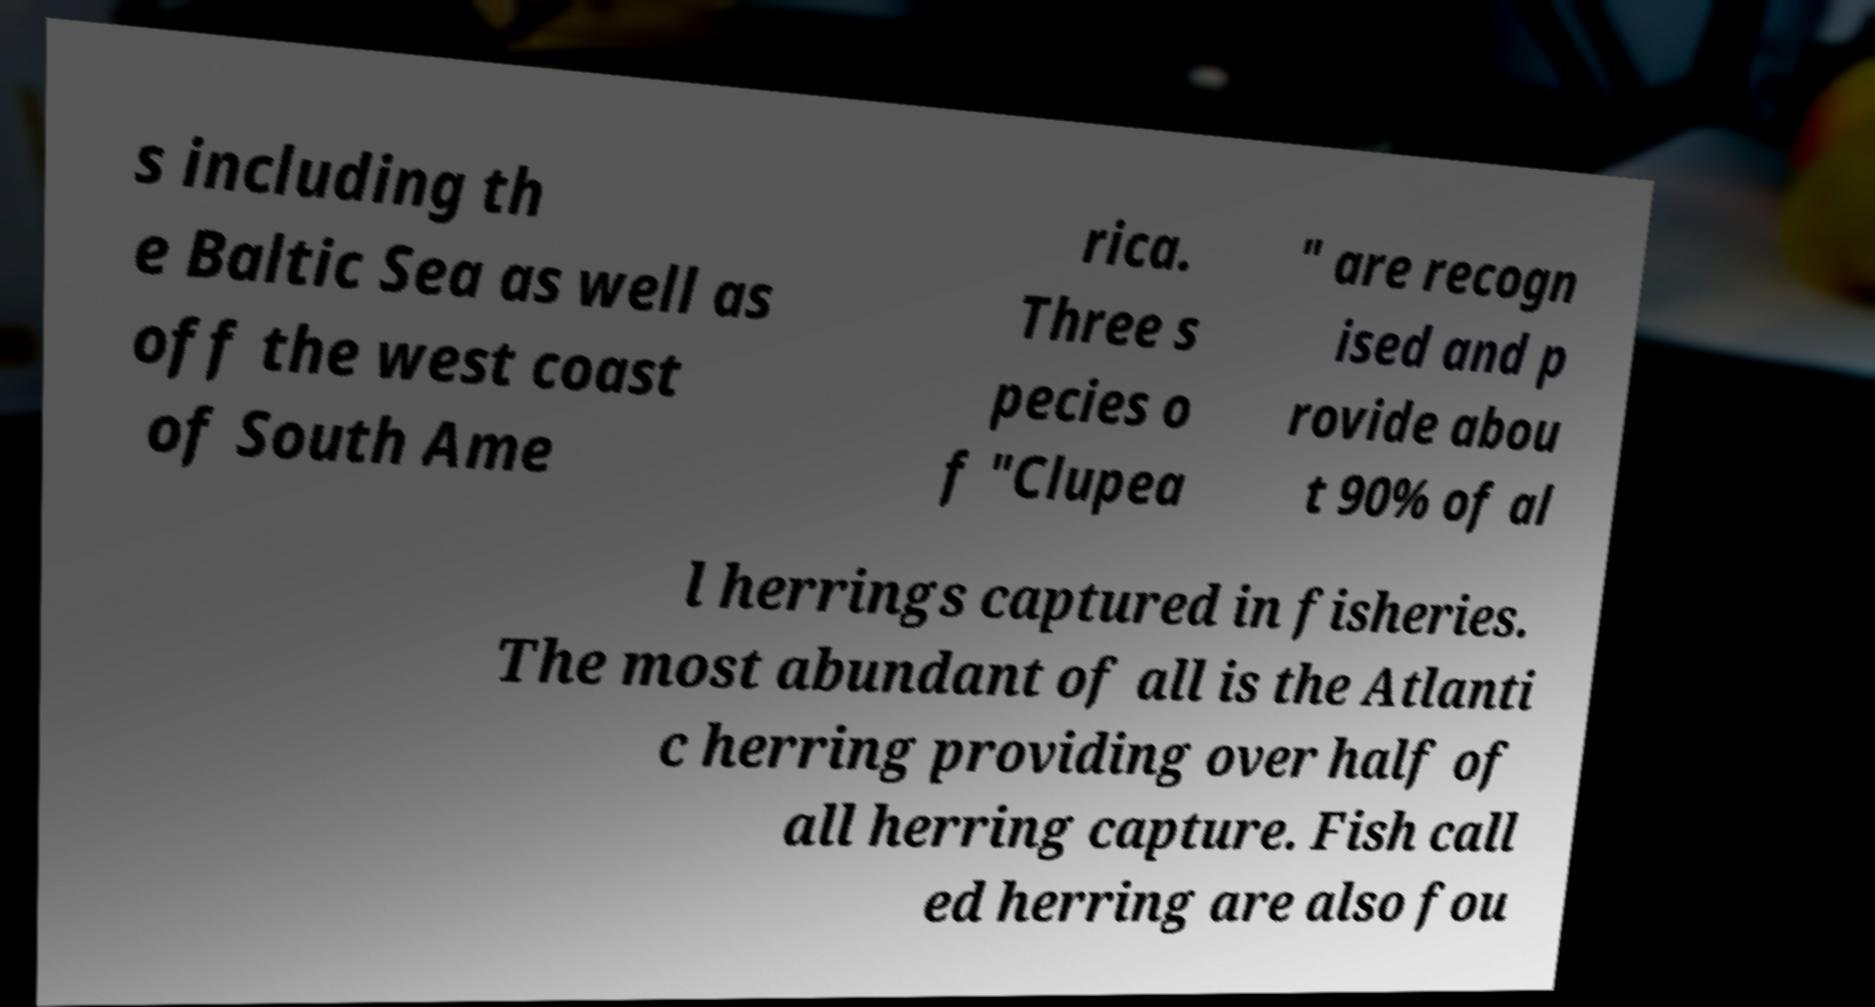Can you accurately transcribe the text from the provided image for me? s including th e Baltic Sea as well as off the west coast of South Ame rica. Three s pecies o f "Clupea " are recogn ised and p rovide abou t 90% of al l herrings captured in fisheries. The most abundant of all is the Atlanti c herring providing over half of all herring capture. Fish call ed herring are also fou 